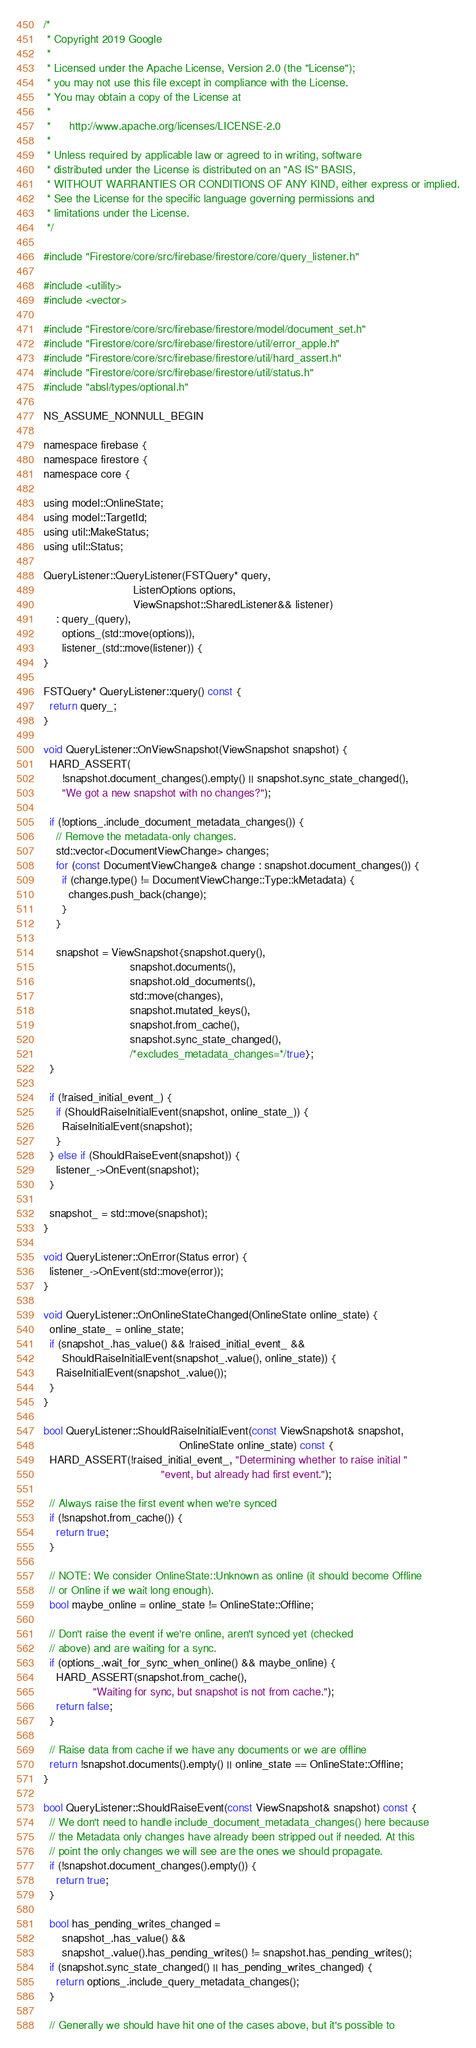Convert code to text. <code><loc_0><loc_0><loc_500><loc_500><_ObjectiveC_>/*
 * Copyright 2019 Google
 *
 * Licensed under the Apache License, Version 2.0 (the "License");
 * you may not use this file except in compliance with the License.
 * You may obtain a copy of the License at
 *
 *      http://www.apache.org/licenses/LICENSE-2.0
 *
 * Unless required by applicable law or agreed to in writing, software
 * distributed under the License is distributed on an "AS IS" BASIS,
 * WITHOUT WARRANTIES OR CONDITIONS OF ANY KIND, either express or implied.
 * See the License for the specific language governing permissions and
 * limitations under the License.
 */

#include "Firestore/core/src/firebase/firestore/core/query_listener.h"

#include <utility>
#include <vector>

#include "Firestore/core/src/firebase/firestore/model/document_set.h"
#include "Firestore/core/src/firebase/firestore/util/error_apple.h"
#include "Firestore/core/src/firebase/firestore/util/hard_assert.h"
#include "Firestore/core/src/firebase/firestore/util/status.h"
#include "absl/types/optional.h"

NS_ASSUME_NONNULL_BEGIN

namespace firebase {
namespace firestore {
namespace core {

using model::OnlineState;
using model::TargetId;
using util::MakeStatus;
using util::Status;

QueryListener::QueryListener(FSTQuery* query,
                             ListenOptions options,
                             ViewSnapshot::SharedListener&& listener)
    : query_(query),
      options_(std::move(options)),
      listener_(std::move(listener)) {
}

FSTQuery* QueryListener::query() const {
  return query_;
}

void QueryListener::OnViewSnapshot(ViewSnapshot snapshot) {
  HARD_ASSERT(
      !snapshot.document_changes().empty() || snapshot.sync_state_changed(),
      "We got a new snapshot with no changes?");

  if (!options_.include_document_metadata_changes()) {
    // Remove the metadata-only changes.
    std::vector<DocumentViewChange> changes;
    for (const DocumentViewChange& change : snapshot.document_changes()) {
      if (change.type() != DocumentViewChange::Type::kMetadata) {
        changes.push_back(change);
      }
    }

    snapshot = ViewSnapshot{snapshot.query(),
                            snapshot.documents(),
                            snapshot.old_documents(),
                            std::move(changes),
                            snapshot.mutated_keys(),
                            snapshot.from_cache(),
                            snapshot.sync_state_changed(),
                            /*excludes_metadata_changes=*/true};
  }

  if (!raised_initial_event_) {
    if (ShouldRaiseInitialEvent(snapshot, online_state_)) {
      RaiseInitialEvent(snapshot);
    }
  } else if (ShouldRaiseEvent(snapshot)) {
    listener_->OnEvent(snapshot);
  }

  snapshot_ = std::move(snapshot);
}

void QueryListener::OnError(Status error) {
  listener_->OnEvent(std::move(error));
}

void QueryListener::OnOnlineStateChanged(OnlineState online_state) {
  online_state_ = online_state;
  if (snapshot_.has_value() && !raised_initial_event_ &&
      ShouldRaiseInitialEvent(snapshot_.value(), online_state)) {
    RaiseInitialEvent(snapshot_.value());
  }
}

bool QueryListener::ShouldRaiseInitialEvent(const ViewSnapshot& snapshot,
                                            OnlineState online_state) const {
  HARD_ASSERT(!raised_initial_event_, "Determining whether to raise initial "
                                      "event, but already had first event.");

  // Always raise the first event when we're synced
  if (!snapshot.from_cache()) {
    return true;
  }

  // NOTE: We consider OnlineState::Unknown as online (it should become Offline
  // or Online if we wait long enough).
  bool maybe_online = online_state != OnlineState::Offline;

  // Don't raise the event if we're online, aren't synced yet (checked
  // above) and are waiting for a sync.
  if (options_.wait_for_sync_when_online() && maybe_online) {
    HARD_ASSERT(snapshot.from_cache(),
                "Waiting for sync, but snapshot is not from cache.");
    return false;
  }

  // Raise data from cache if we have any documents or we are offline
  return !snapshot.documents().empty() || online_state == OnlineState::Offline;
}

bool QueryListener::ShouldRaiseEvent(const ViewSnapshot& snapshot) const {
  // We don't need to handle include_document_metadata_changes() here because
  // the Metadata only changes have already been stripped out if needed. At this
  // point the only changes we will see are the ones we should propagate.
  if (!snapshot.document_changes().empty()) {
    return true;
  }

  bool has_pending_writes_changed =
      snapshot_.has_value() &&
      snapshot_.value().has_pending_writes() != snapshot.has_pending_writes();
  if (snapshot.sync_state_changed() || has_pending_writes_changed) {
    return options_.include_query_metadata_changes();
  }

  // Generally we should have hit one of the cases above, but it's possible to</code> 